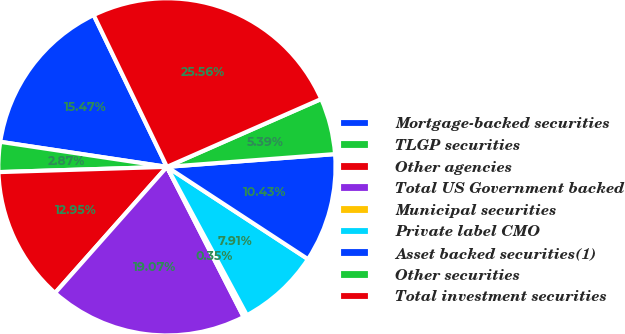Convert chart. <chart><loc_0><loc_0><loc_500><loc_500><pie_chart><fcel>Mortgage-backed securities<fcel>TLGP securities<fcel>Other agencies<fcel>Total US Government backed<fcel>Municipal securities<fcel>Private label CMO<fcel>Asset backed securities(1)<fcel>Other securities<fcel>Total investment securities<nl><fcel>15.47%<fcel>2.87%<fcel>12.95%<fcel>19.07%<fcel>0.35%<fcel>7.91%<fcel>10.43%<fcel>5.39%<fcel>25.56%<nl></chart> 